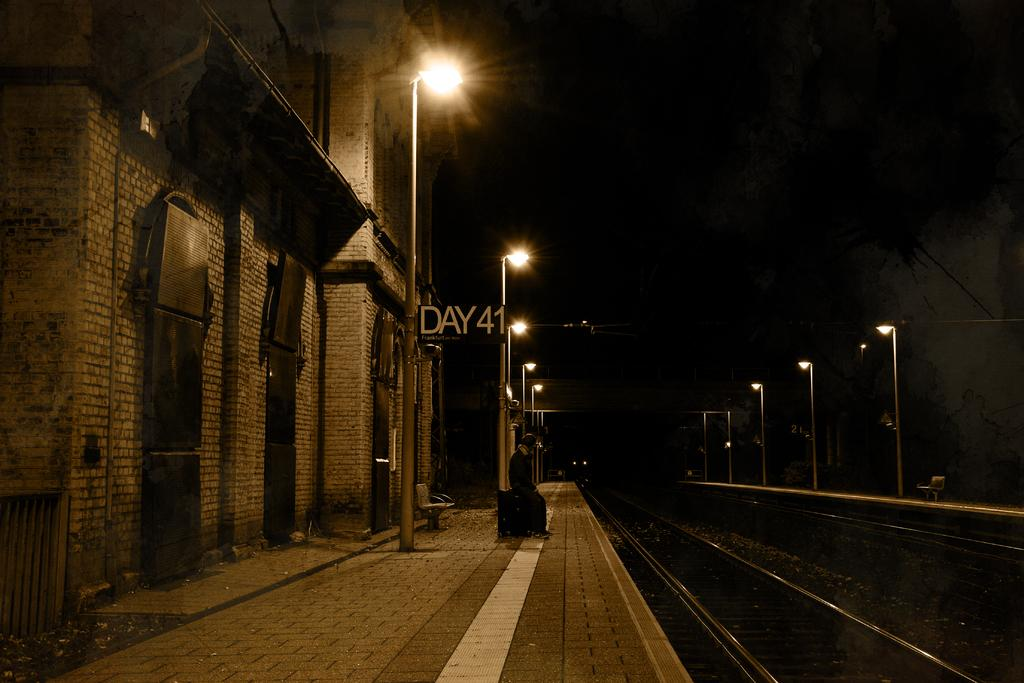<image>
Write a terse but informative summary of the picture. A dark street with lights and a sign that says Day 41. 